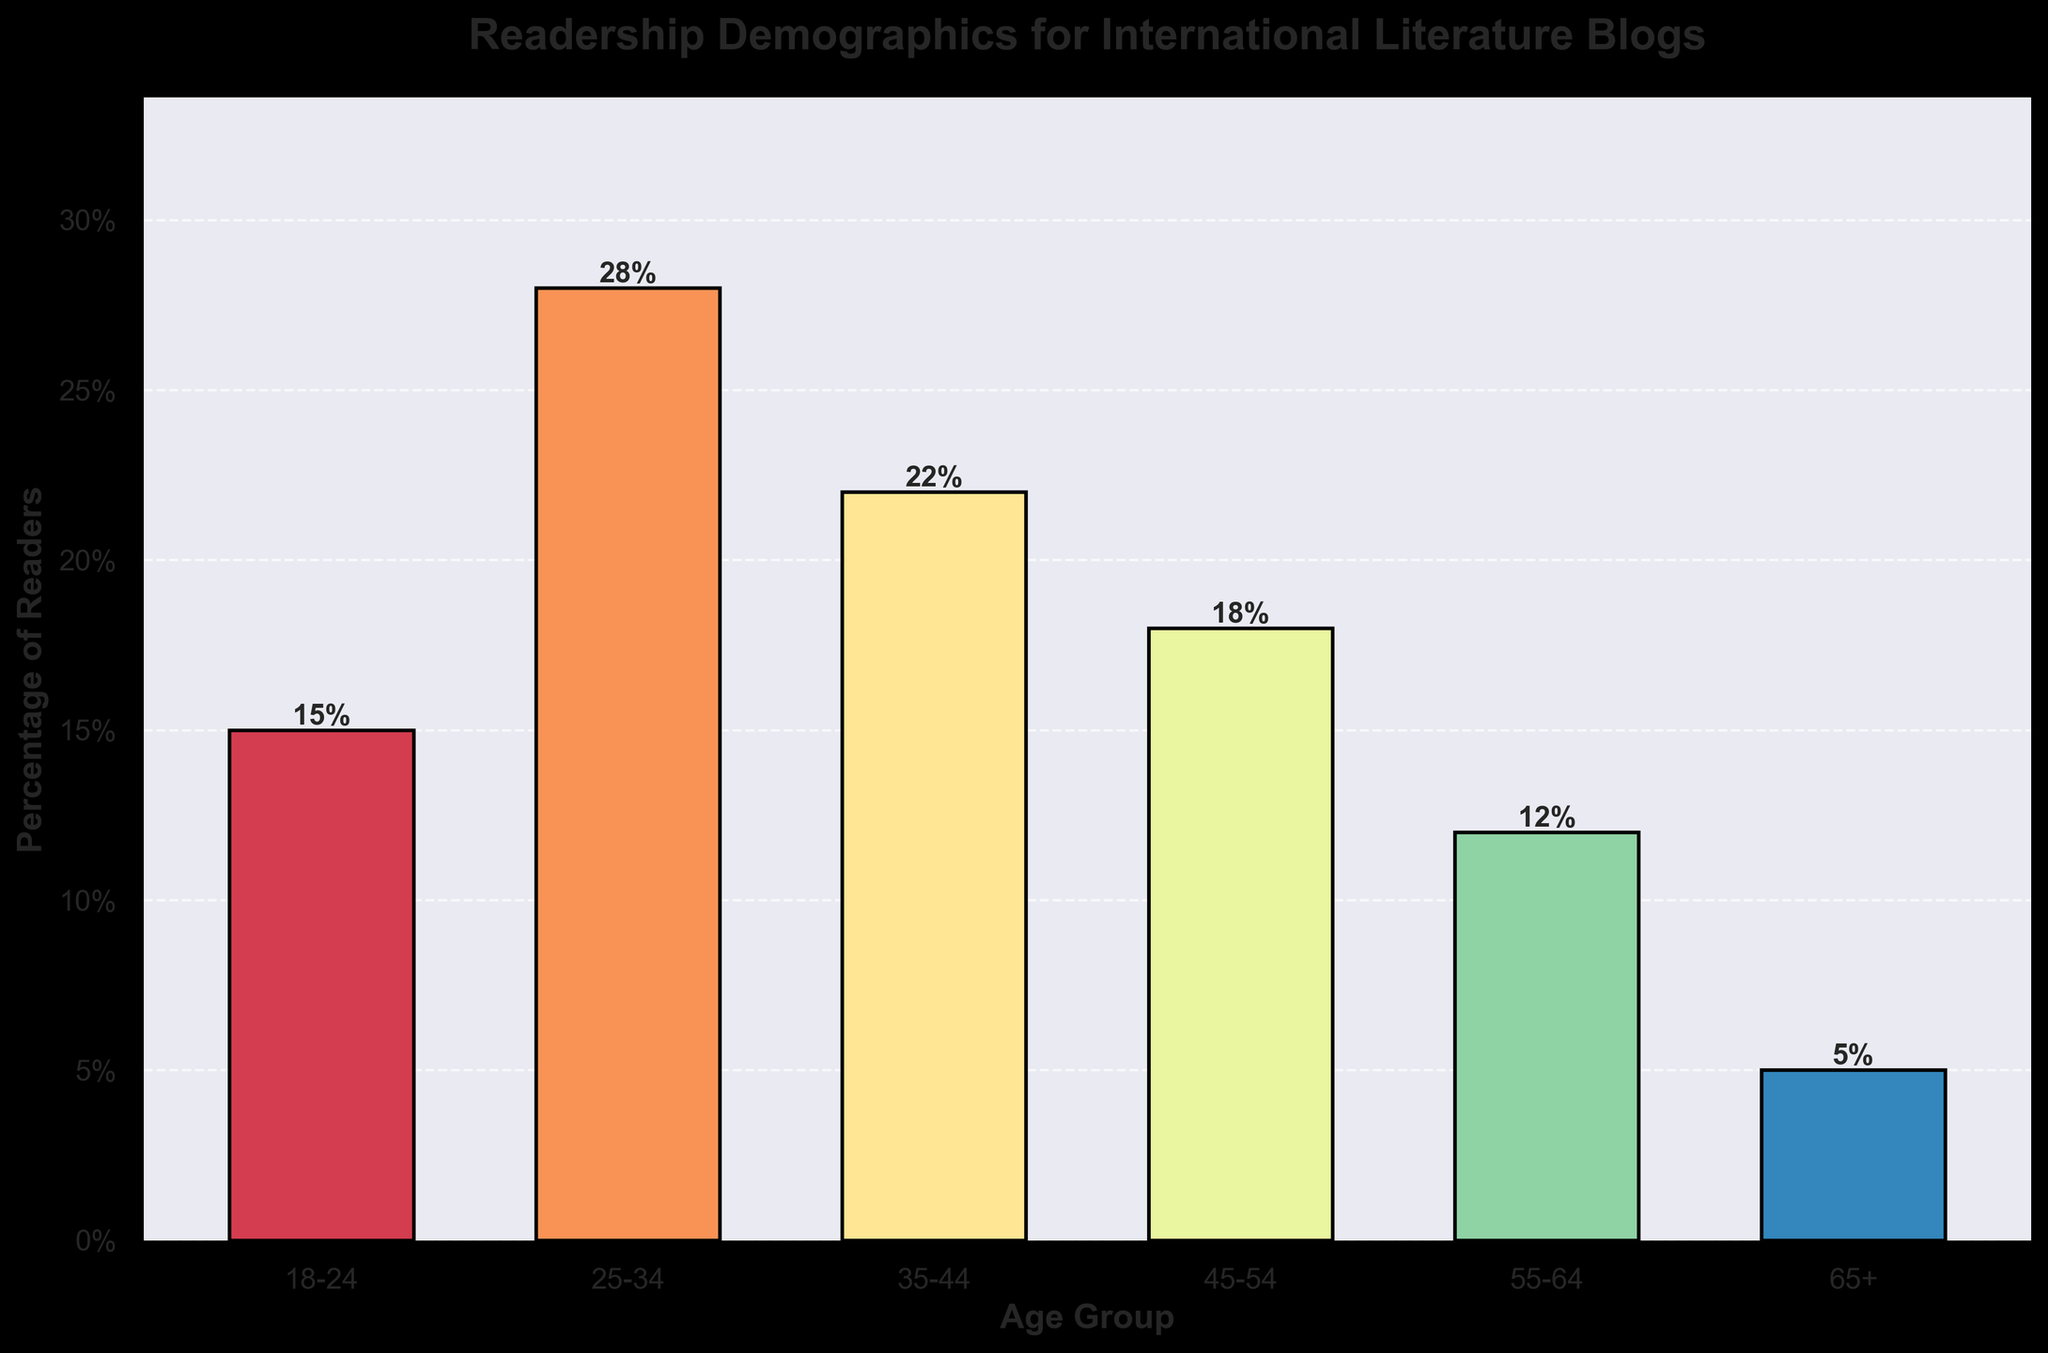What is the age group with the highest percentage of readers? The figure shows that the bar representing the 25-34 age group is the tallest, indicating it has the highest percentage of readers.
Answer: 25-34 How much higher is the percentage of readers in the 25-34 age group compared to the 65+ age group? The 25-34 age group has a percentage of 28% and the 65+ age group has a percentage of 5%. The difference is 28% - 5% = 23%.
Answer: 23% Which age group has a percentage closest to 20%? Examining the visual heights of the bars, the age group 35-44 has a percentage of 22%, which is closest to 20%.
Answer: 35-44 What is the total percentage of readers for the age groups 18-24, 35-44, and 55-64? Adding the percentages of the 18-24 (15%), 35-44 (22%), and 55-64 (12%) age groups gives: 15% + 22% + 12% = 49%.
Answer: 49% Compare the percentage of readers in the age group 45-54 with the age group 18-24. Which is higher, and by how much? The percentage for 45-54 is 18% and for 18-24 is 15%. The 45-54 age group’s percentage is higher by 18% - 15% = 3%.
Answer: 45-54 by 3% What is the combined percentage of readers younger than 35 years old? Summing the percentages of the 18-24 (15%) and 25-34 (28%) age groups, we get 15% + 28% = 43%.
Answer: 43% By how much does the percentage of readers in the 25-34 age group exceed the sum of the percentages of the 55-64 and 65+ age groups? The sum of the 55-64 (12%) and 65+ (5%) age groups is 12% + 5% = 17%. The percentage for the 25-34 age group is 28%. The difference is 28% - 17% = 11%.
Answer: 11% Identify the age groups that together form exactly 40% of the total readership. Combining the percentages for the 45-54 (18%) and 55-64 (12%) age groups, we get 18% + 12% = 30%. Including the next lowest age group, 65+ (5%), the total becomes 35%. Including the next smallest group, 18-24 (15%) leads to 50%. Therefore, the exact combination cannot be precisely 40% using the given groups.
Answer: Not possible What is the average percentage of all age groups combined? Summing all percentages (15%, 28%, 22%, 18%, 12%, 5%) gives a total of 100%. Dividing by the number of age groups (6) gives an average: 100% / 6 ≈ 16.67%.
Answer: 16.67% Which two age groups have a combined percentage of readers equal to that of the 35-44 age group? The 35-44 age group has 22%. Combining the 55-64 (12%) and 65+ (5%) age groups yields 12% + 5% = 17%, and combining with the next smallest group, 18-24 (15%) results in 15% + 5% = 20% which is closest. However, combining 18-24 (15%) and 55-64 (12%) gives 27%. Therefore, 45-54 (18%) and 65+ (5%) results in 18% + 5% = 23%. Thus the right combination cannot equate to exactly 22%.
Answer: Not possible 